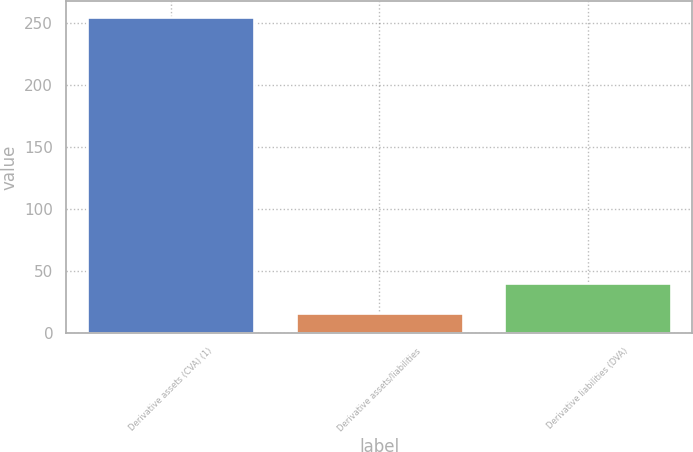<chart> <loc_0><loc_0><loc_500><loc_500><bar_chart><fcel>Derivative assets (CVA) (1)<fcel>Derivative assets/liabilities<fcel>Derivative liabilities (DVA)<nl><fcel>255<fcel>16<fcel>39.9<nl></chart> 